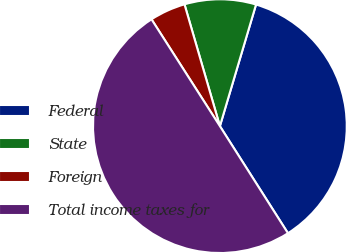Convert chart to OTSL. <chart><loc_0><loc_0><loc_500><loc_500><pie_chart><fcel>Federal<fcel>State<fcel>Foreign<fcel>Total income taxes for<nl><fcel>36.39%<fcel>9.1%<fcel>4.56%<fcel>49.95%<nl></chart> 